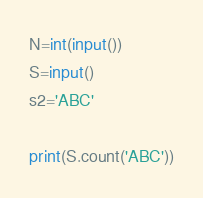Convert code to text. <code><loc_0><loc_0><loc_500><loc_500><_Python_>N=int(input())
S=input()
s2='ABC'

print(S.count('ABC'))</code> 